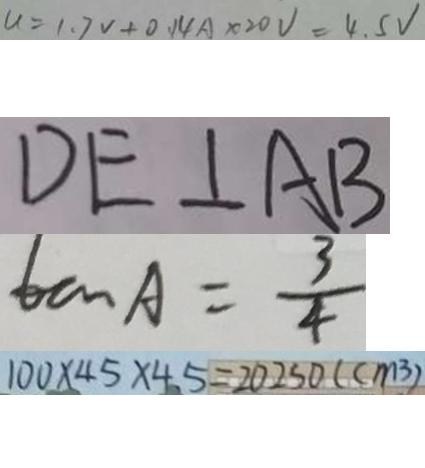Convert formula to latex. <formula><loc_0><loc_0><loc_500><loc_500>u = 1 . 7 v + 0 . 1 4 A \times 2 0 V = 4 . 5 V 
 D E \bot A B 
 \tan A = \frac { 3 } { 4 } 
 1 0 0 \times 4 5 \times 4 5 = 2 0 2 5 0 ( c m ^ { 3 } )</formula> 